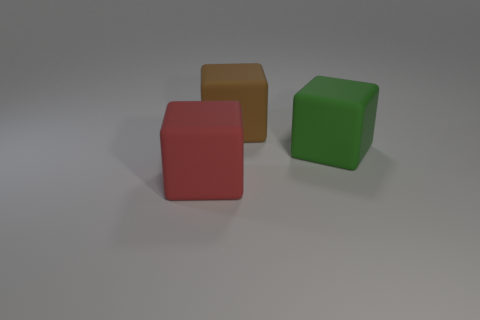What number of matte objects have the same size as the brown matte block?
Give a very brief answer. 2. What is the shape of the big thing that is on the left side of the large block behind the green block?
Your answer should be compact. Cube. Is the number of red matte things less than the number of large objects?
Offer a very short reply. Yes. What is the color of the large matte block behind the green object?
Ensure brevity in your answer.  Brown. There is a thing that is both behind the big red object and on the left side of the green rubber thing; what material is it?
Your answer should be very brief. Rubber. There is a red thing that is the same material as the brown thing; what shape is it?
Your answer should be very brief. Cube. There is a large matte cube that is in front of the large green block; how many cubes are behind it?
Provide a short and direct response. 2. How many large things are left of the big green thing and to the right of the large red block?
Offer a very short reply. 1. How many other things are made of the same material as the brown cube?
Give a very brief answer. 2. There is a big rubber block that is on the left side of the block that is behind the big green rubber block; what is its color?
Make the answer very short. Red. 